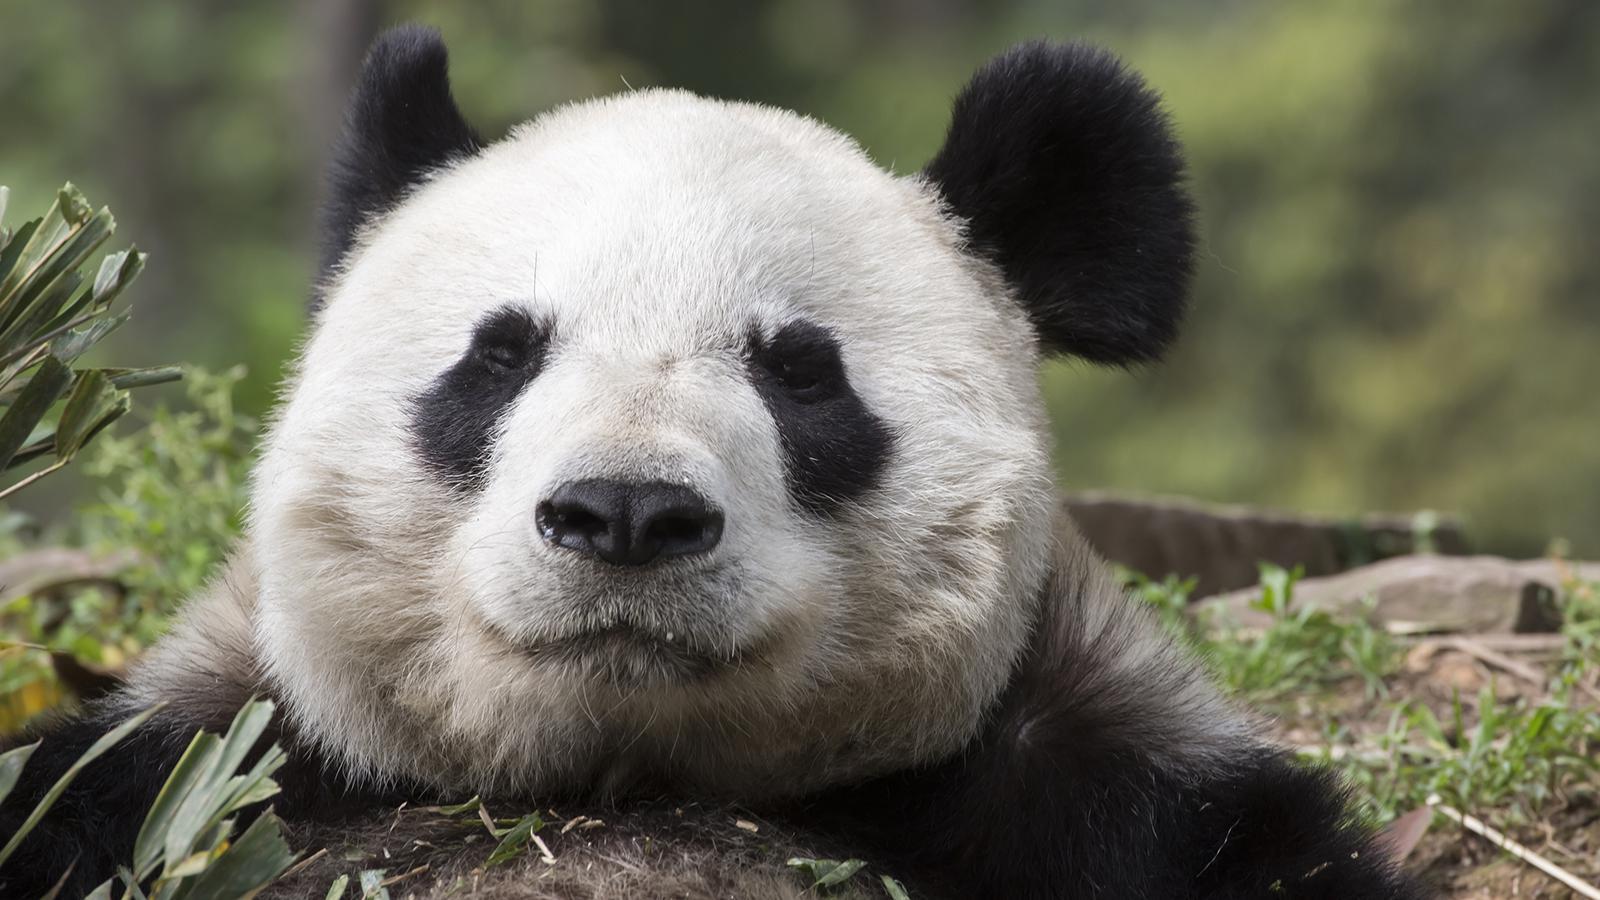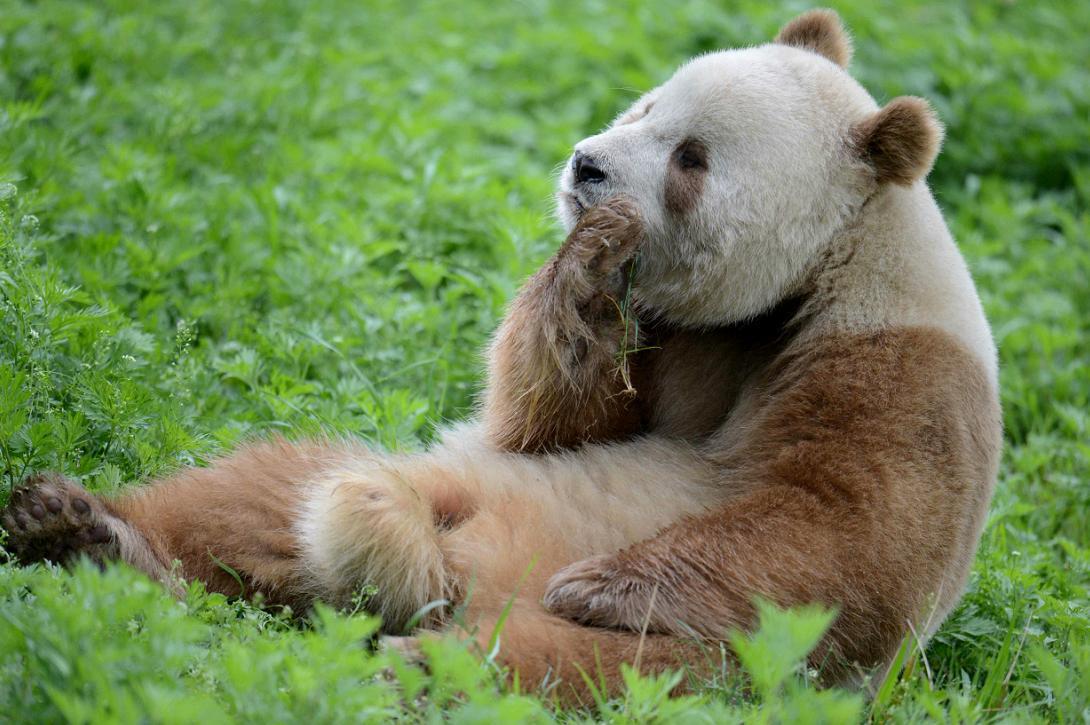The first image is the image on the left, the second image is the image on the right. Examine the images to the left and right. Is the description "There are two black and white panda bears" accurate? Answer yes or no. No. The first image is the image on the left, the second image is the image on the right. Analyze the images presented: Is the assertion "One of the pandas is on all fours." valid? Answer yes or no. No. 